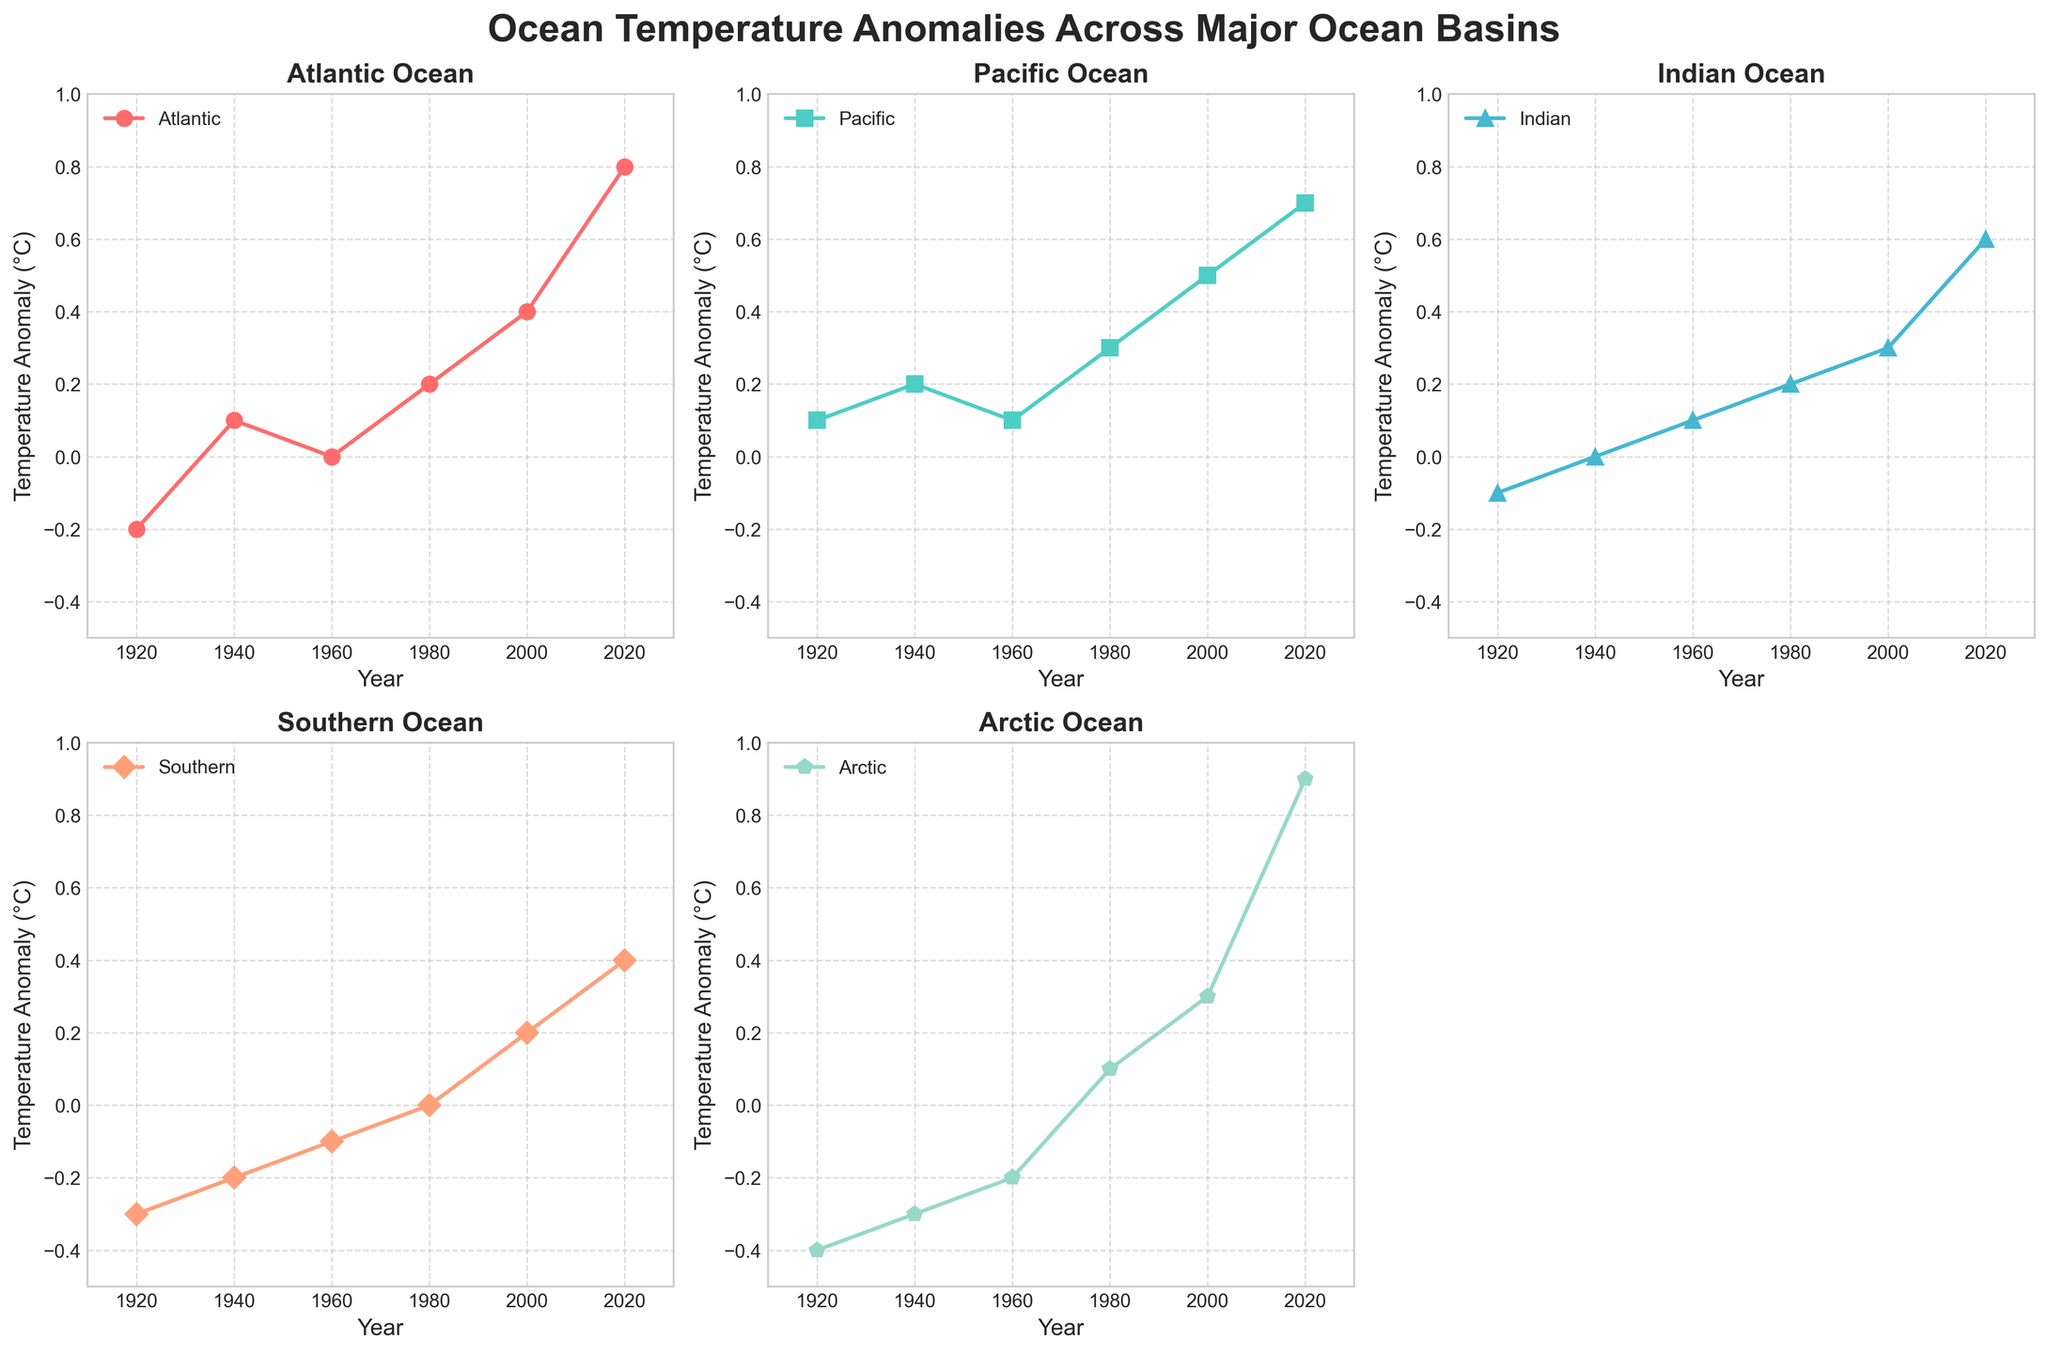Which ocean basin shows the highest temperature anomaly in 2020? The subplot for 2020 shows that the Arctic Ocean has the highest temperature anomaly with 0.9°C compared to the other major ocean basins.
Answer: Arctic Between which years did the Pacific Ocean's temperature anomaly increase the most? By looking at the curve in the subplot for the Pacific Ocean, the most significant increase occurs between 2000 and 2020, where the anomaly rises from 0.5°C to 0.7°C.
Answer: 2000 and 2020 What was the temperature anomaly for the Indian Ocean in 1980? The subplot for the Indian Ocean shows the anomaly in 1980 marked at 0.2°C.
Answer: 0.2°C How does the temperature anomaly trend over time in the Atlantic Ocean? The Atlantic Ocean's temperature anomaly starts at -0.2°C in 1920, then increases steadily to 0.8°C in 2020. The overall trend shows a consistent warming.
Answer: Increasing Which years show a negative temperature anomaly for the Southern Ocean? The Southern Ocean subplot shows negative temperature anomalies in 1920 (-0.3°C), 1940 (-0.2°C), and 1960 (-0.1°C).
Answer: 1920, 1940, 1960 Compare the temperature anomaly trends for the Atlantic Ocean and the Arctic Ocean. Which shows a more rapid increase over the century? By comparing the subplots, the Arctic Ocean starts at -0.4°C in 1920 and goes up to 0.9°C in 2020, while the Atlantic Ocean starts at -0.2°C and rises to 0.8°C. The Arctic Ocean shows a more rapid increase.
Answer: Arctic Ocean What is the overall temperature anomaly trend for the Indian Ocean from 1920 to 2020? The Indian Ocean's temperature anomaly increases consistently from -0.1°C in 1920 to 0.6°C in 2020. It indicates a consistent warming trend.
Answer: Increasing Which ocean basin has its first positive temperature anomaly, and in what year does it occur? The first positive anomalies appear in the Atlantic Ocean (1940, 0.1°C) and Pacific Ocean (1940, 0.2°C). The Atlantic Ocean had its positive anomaly first in alphabetical comparison.
Answer: Atlantic, 1940 Which ocean basin has the least temperature anomaly variation over the century? The Indian Ocean shows the least variation, starting at -0.1°C in 1920 and rising to 0.6°C by 2020, a total shift of 0.7°C.
Answer: Indian Ocean How many subplots are present in the grid, and which one is empty? There are a total of 5 subplots present in the 2x3 grid, with the subplot in the second row and third column being empty.
Answer: 5, second row third column 